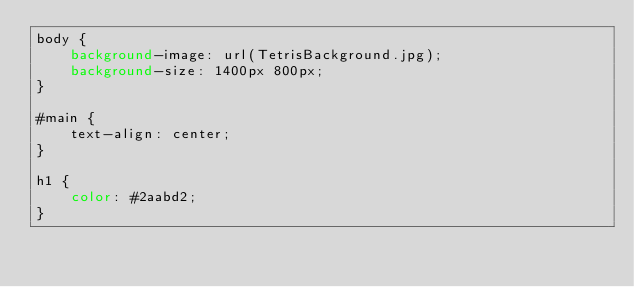<code> <loc_0><loc_0><loc_500><loc_500><_CSS_>body {
	background-image: url(TetrisBackground.jpg);
	background-size: 1400px 800px;
}

#main {
	text-align: center;
}

h1 {
	color: #2aabd2;
}</code> 